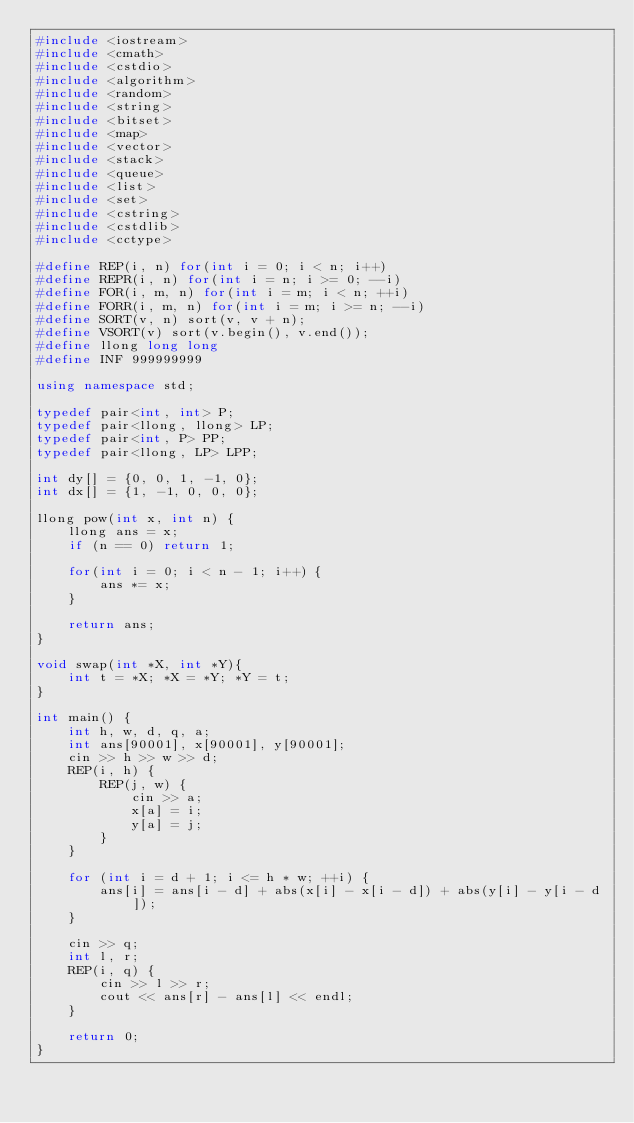Convert code to text. <code><loc_0><loc_0><loc_500><loc_500><_C++_>#include <iostream>
#include <cmath>
#include <cstdio>
#include <algorithm>
#include <random>
#include <string>
#include <bitset>
#include <map>
#include <vector>
#include <stack>
#include <queue>
#include <list>
#include <set>
#include <cstring>
#include <cstdlib>
#include <cctype>

#define REP(i, n) for(int i = 0; i < n; i++)
#define REPR(i, n) for(int i = n; i >= 0; --i)
#define FOR(i, m, n) for(int i = m; i < n; ++i)
#define FORR(i, m, n) for(int i = m; i >= n; --i)
#define SORT(v, n) sort(v, v + n);
#define VSORT(v) sort(v.begin(), v.end());
#define llong long long
#define INF 999999999

using namespace std;

typedef pair<int, int> P;
typedef pair<llong, llong> LP;
typedef pair<int, P> PP;
typedef pair<llong, LP> LPP;

int dy[] = {0, 0, 1, -1, 0};
int dx[] = {1, -1, 0, 0, 0};

llong pow(int x, int n) {
    llong ans = x;
    if (n == 0) return 1;

    for(int i = 0; i < n - 1; i++) {
        ans *= x;
    }

    return ans;
}

void swap(int *X, int *Y){
    int t = *X; *X = *Y; *Y = t;
}

int main() {
    int h, w, d, q, a;
    int ans[90001], x[90001], y[90001];
    cin >> h >> w >> d;
    REP(i, h) {
        REP(j, w) {
            cin >> a;
            x[a] = i;
            y[a] = j;
        }
    }

    for (int i = d + 1; i <= h * w; ++i) {
        ans[i] = ans[i - d] + abs(x[i] - x[i - d]) + abs(y[i] - y[i - d]);
    }

    cin >> q;
    int l, r;
    REP(i, q) {
        cin >> l >> r;
        cout << ans[r] - ans[l] << endl;
    }

    return 0;
}</code> 